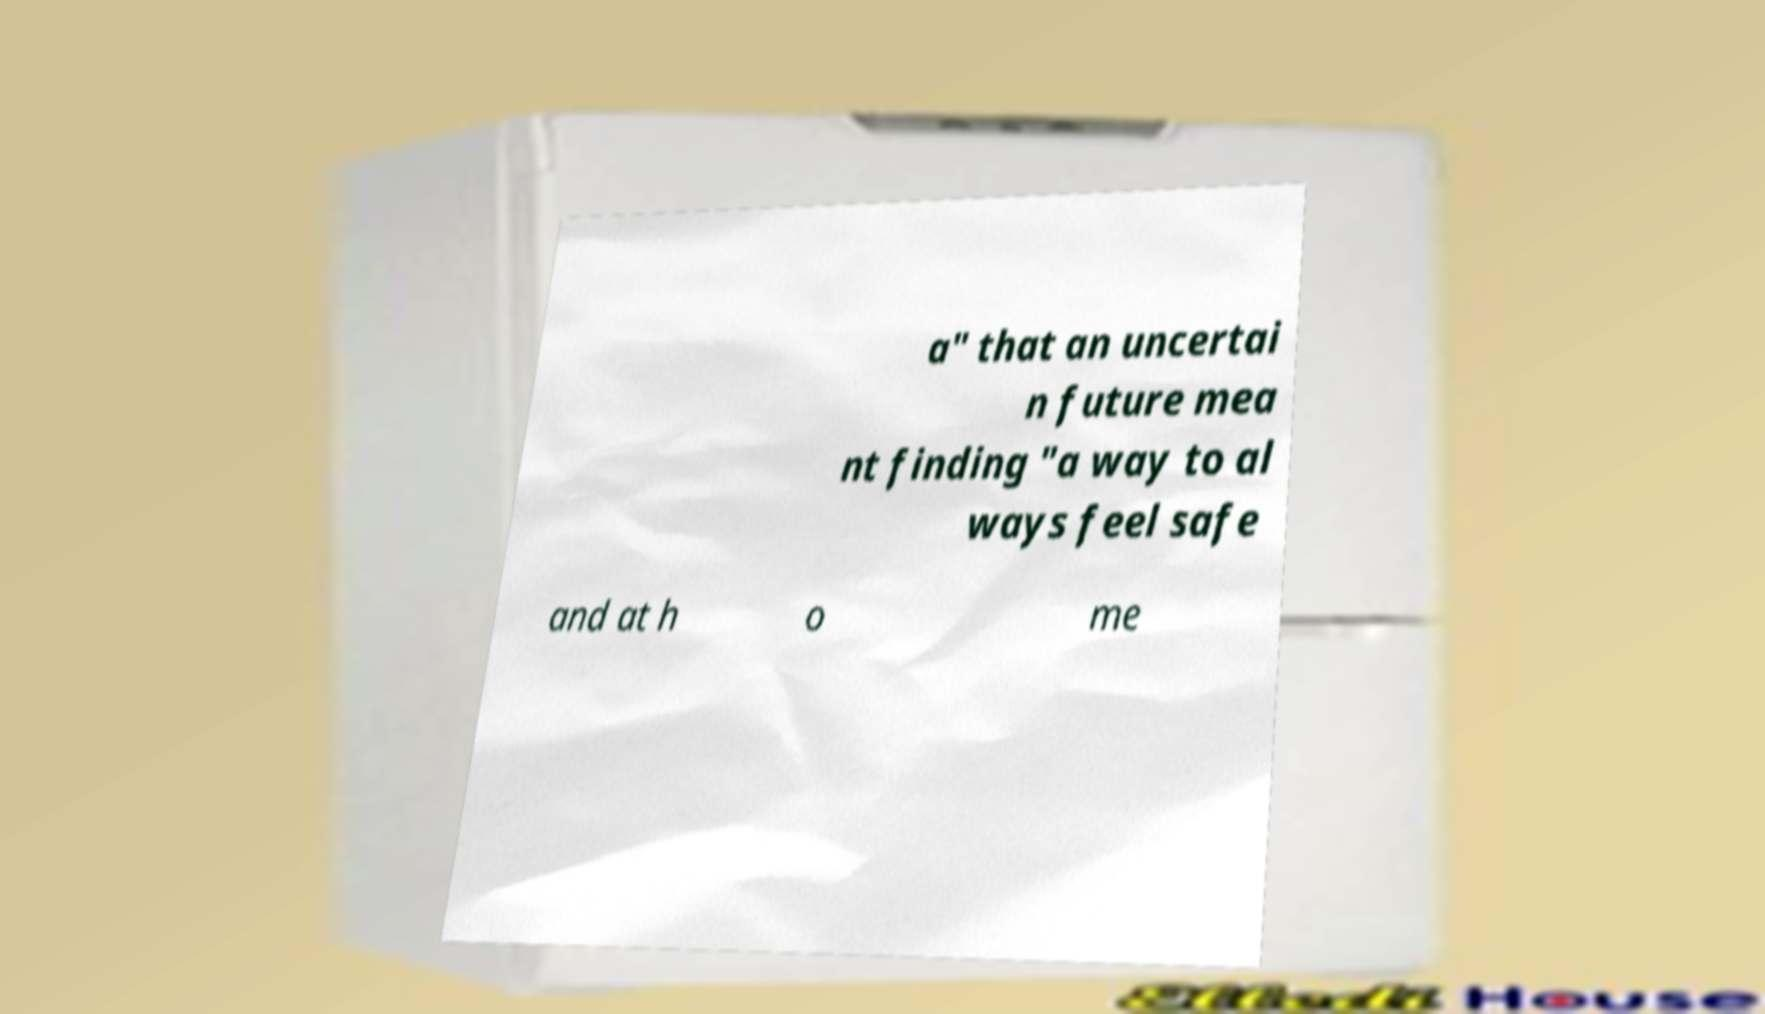Could you assist in decoding the text presented in this image and type it out clearly? a" that an uncertai n future mea nt finding "a way to al ways feel safe and at h o me 